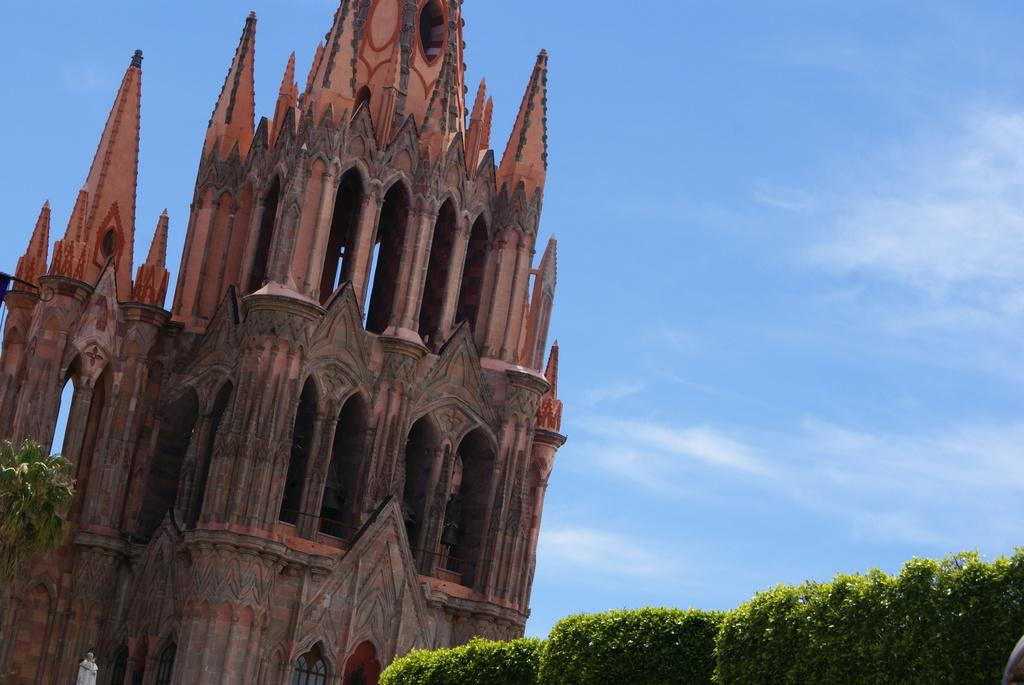What structure is located on the left side of the image? There is a building on the left side of the image. What type of vegetation is on the right side of the image? There are plants on the right side of the image. What is visible in the background of the image? The sky is visible in the background of the image. What can be seen in the sky? There are clouds in the sky. How many bananas are being used to care for the plants in the image? There are no bananas present in the image, and they are not being used to care for the plants. What type of pail is visible in the image? There is no pail visible in the image. 